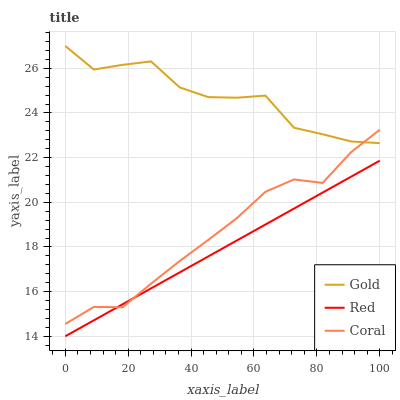Does Gold have the minimum area under the curve?
Answer yes or no. No. Does Red have the maximum area under the curve?
Answer yes or no. No. Is Gold the smoothest?
Answer yes or no. No. Is Red the roughest?
Answer yes or no. No. Does Gold have the lowest value?
Answer yes or no. No. Does Red have the highest value?
Answer yes or no. No. Is Red less than Gold?
Answer yes or no. Yes. Is Gold greater than Red?
Answer yes or no. Yes. Does Red intersect Gold?
Answer yes or no. No. 